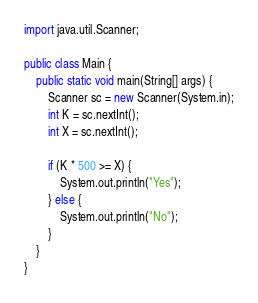<code> <loc_0><loc_0><loc_500><loc_500><_Java_>import java.util.Scanner;

public class Main {
    public static void main(String[] args) {
        Scanner sc = new Scanner(System.in);
        int K = sc.nextInt();
        int X = sc.nextInt();

        if (K * 500 >= X) {
            System.out.println("Yes");
        } else {
            System.out.println("No");
        }
    }
}</code> 